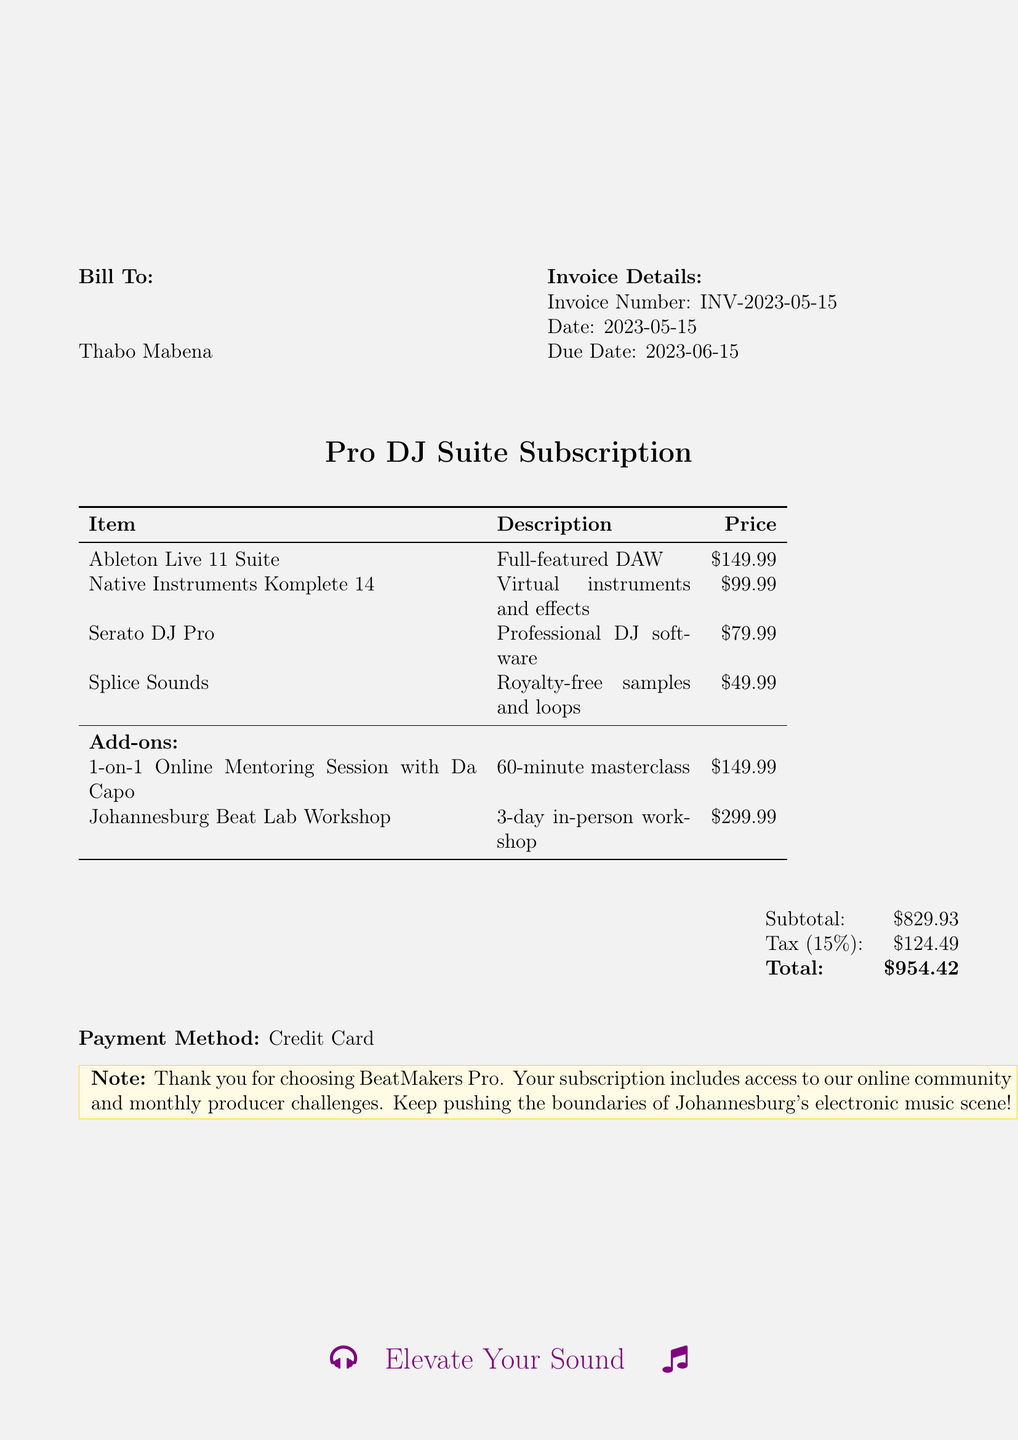What is the invoice number? The invoice number is listed under the invoice details section of the document.
Answer: INV-2023-05-15 What is the due date? The due date is provided in the invoice details section.
Answer: 2023-06-15 Who is the bill to? The bill to section specifies the name of the individual or entity receiving the invoice.
Answer: Thabo Mabena What is the price of Ableton Live 11 Suite? The price is listed alongside the item description in the invoice.
Answer: $149.99 How much is the total amount due? The total amount is calculated at the end of the document under the total section.
Answer: $954.42 What is included in the Pro DJ Suite Subscription? The subscription details and items covered in the subscription are provided in the itemized list.
Answer: Ableton Live 11 Suite, Native Instruments Komplete 14, Serato DJ Pro, Splice Sounds What is the tax rate applied? The tax rate is mentioned next to the tax amount in the invoice.
Answer: 15% What is the duration of the workshop? The workshop duration is specified in the description of the add-on course.
Answer: 3-day What method of payment is specified? The payment method is indicated towards the bottom of the document.
Answer: Credit Card What add-on is available for mentoring? The add-on for mentoring is listed in the add-ons section of the invoice.
Answer: 1-on-1 Online Mentoring Session with Da Capo 